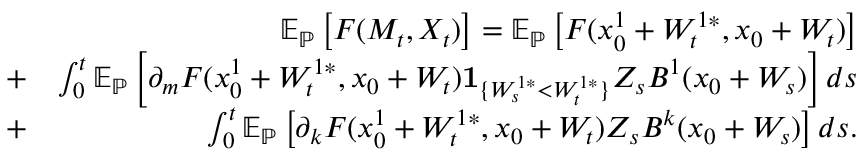<formula> <loc_0><loc_0><loc_500><loc_500>\begin{array} { r l r } & { { \mathbb { E } } _ { \mathbb { P } } \left [ F ( M _ { t } , X _ { t } ) \right ] = { \mathbb { E } } _ { \mathbb { P } } \left [ F ( x _ { 0 } ^ { 1 } + W _ { t } ^ { 1 * } , x _ { 0 } + W _ { t } ) \right ] } \\ & { + } & { \int _ { 0 } ^ { t } { \mathbb { E } } _ { \mathbb { P } } \left [ \partial _ { m } F ( x _ { 0 } ^ { 1 } + W _ { t } ^ { 1 * } , x _ { 0 } + W _ { t } ) { \mathbf 1 } _ { \{ W _ { s } ^ { 1 * } < W _ { t } ^ { 1 * } \} } Z _ { s } B ^ { 1 } ( x _ { 0 } + W _ { s } ) \right ] d s } \\ & { + } & { \int _ { 0 } ^ { t } { \mathbb { E } } _ { \mathbb { P } } \left [ \partial _ { k } F ( x _ { 0 } ^ { 1 } + W _ { t } ^ { 1 * } , x _ { 0 } + W _ { t } ) Z _ { s } B ^ { k } ( x _ { 0 } + W _ { s } ) \right ] d s . } \end{array}</formula> 